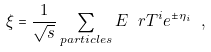<formula> <loc_0><loc_0><loc_500><loc_500>\xi = \frac { 1 } { \sqrt { s } } \sum _ { p a r t i c l e s } E _ { \ } r T ^ { i } e ^ { \pm \eta _ { i } } \ ,</formula> 